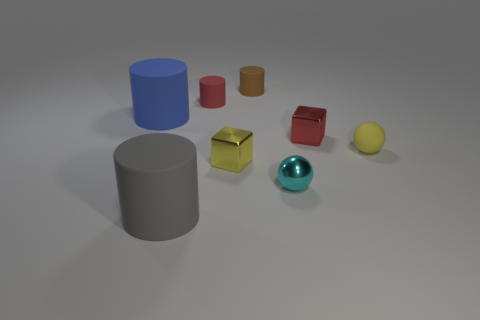Subtract 1 cylinders. How many cylinders are left? 3 Subtract all large blue cylinders. How many cylinders are left? 3 Subtract all green cylinders. Subtract all gray balls. How many cylinders are left? 4 Add 2 small brown cylinders. How many objects exist? 10 Subtract all balls. How many objects are left? 6 Subtract all tiny red matte things. Subtract all cyan metallic balls. How many objects are left? 6 Add 8 yellow shiny blocks. How many yellow shiny blocks are left? 9 Add 7 small brown cylinders. How many small brown cylinders exist? 8 Subtract 0 brown cubes. How many objects are left? 8 